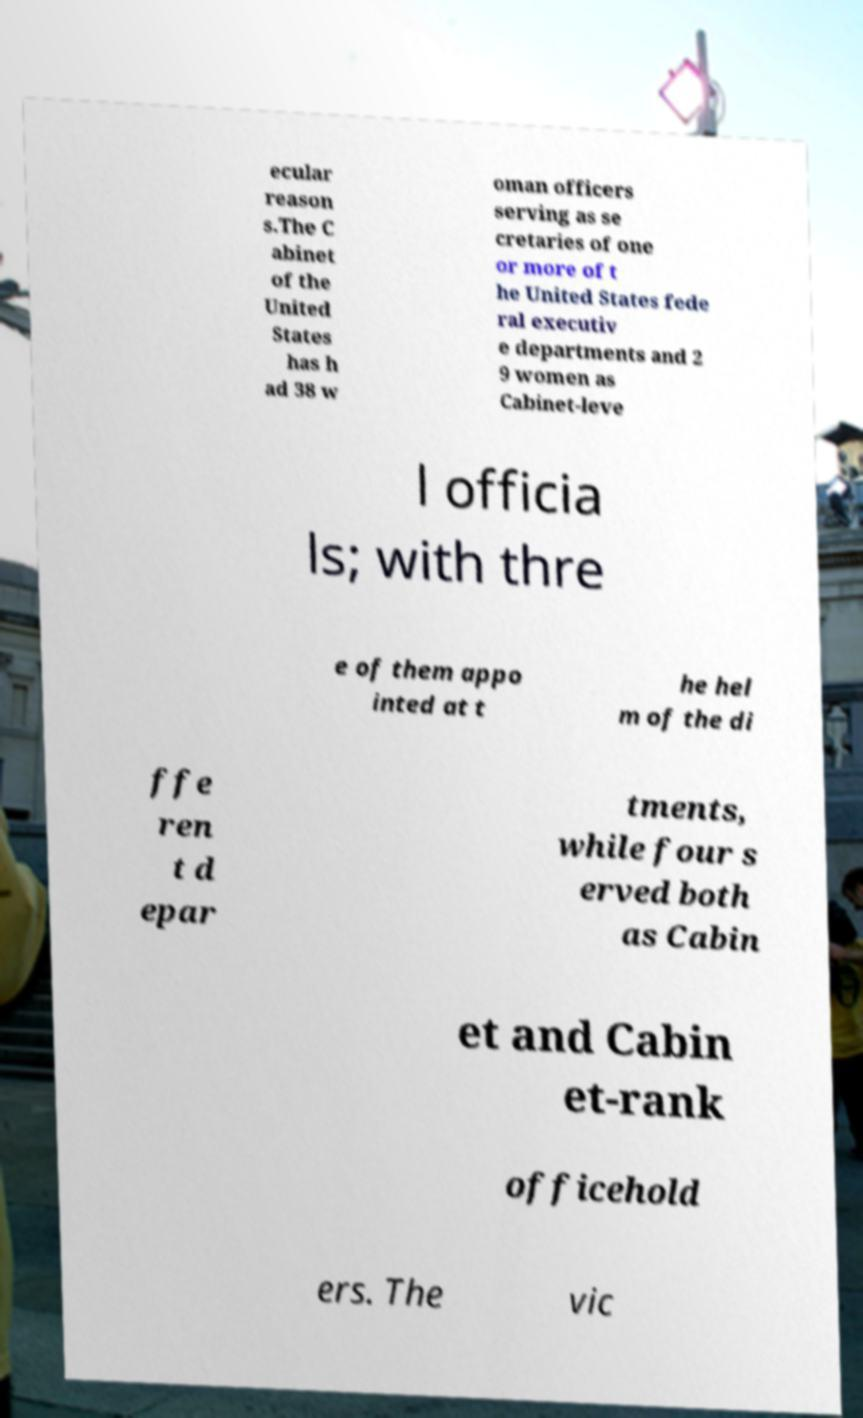Can you accurately transcribe the text from the provided image for me? ecular reason s.The C abinet of the United States has h ad 38 w oman officers serving as se cretaries of one or more of t he United States fede ral executiv e departments and 2 9 women as Cabinet-leve l officia ls; with thre e of them appo inted at t he hel m of the di ffe ren t d epar tments, while four s erved both as Cabin et and Cabin et-rank officehold ers. The vic 